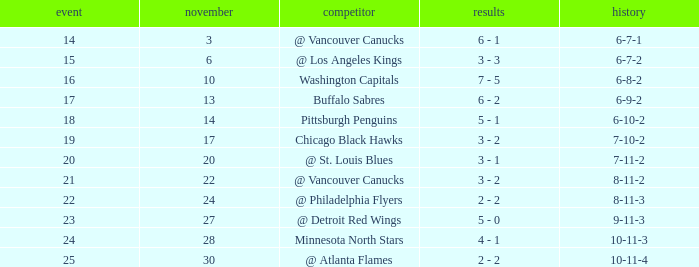What is the game when on november 27? 23.0. 